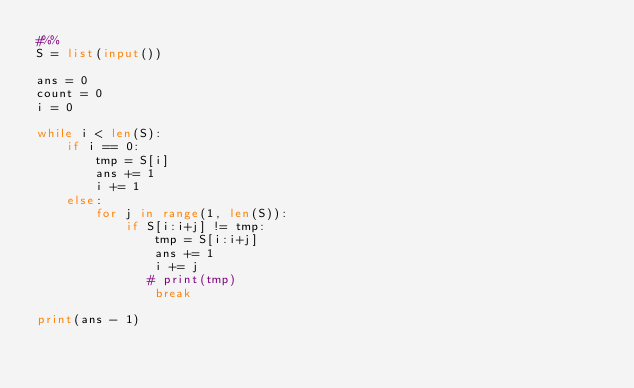<code> <loc_0><loc_0><loc_500><loc_500><_Python_>#%%
S = list(input())

ans = 0
count = 0
i = 0

while i < len(S):
    if i == 0:
        tmp = S[i]
        ans += 1
        i += 1
    else:
        for j in range(1, len(S)):
            if S[i:i+j] != tmp:
                tmp = S[i:i+j]
                ans += 1
                i += j
               # print(tmp)
                break

print(ans - 1)

</code> 